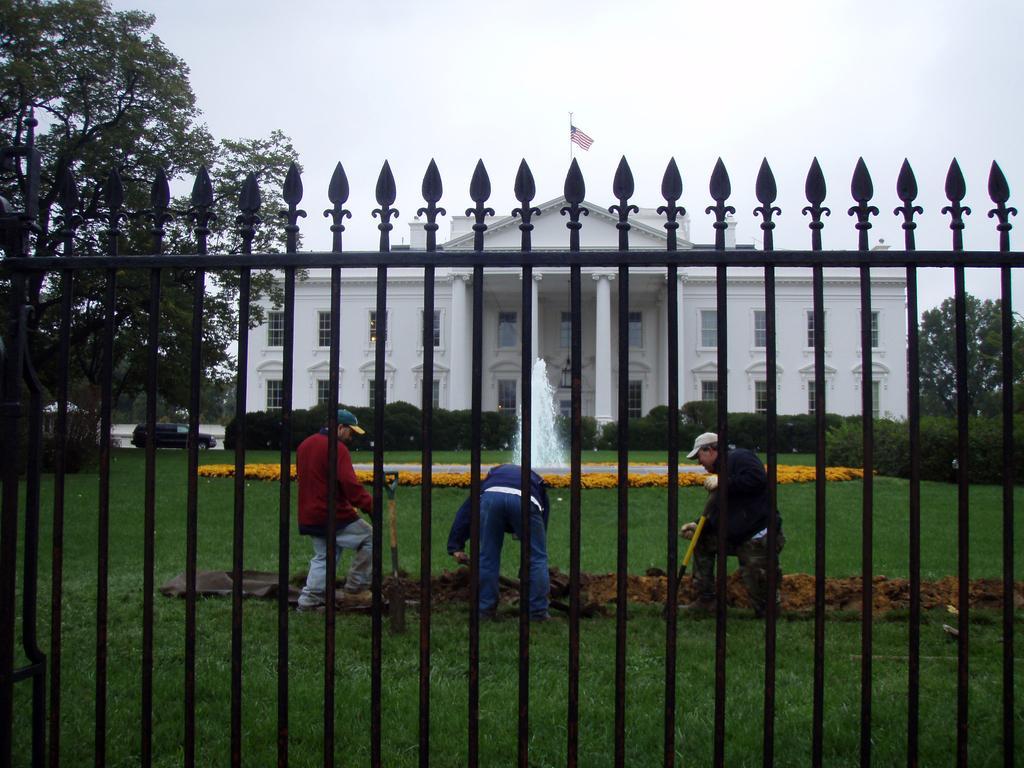In one or two sentences, can you explain what this image depicts? In the center of the image we can see a building, windows, pillars, flag, pole, bushes, fountain, flowers and three people are holding the objects and wearing the caps and digging the ground. In the background of the image we can see the trees, grass, car, road and grilles. At the bottom of the image we can see the ground. At the top of the image we can see the sky. 